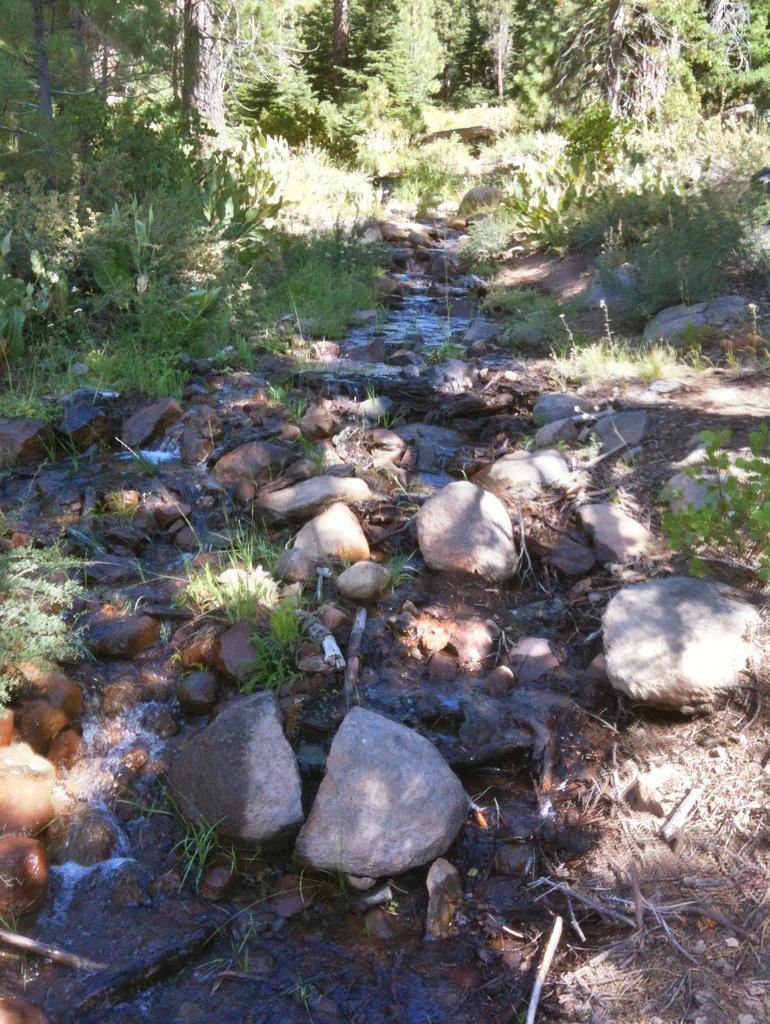What is located in the middle of the image? There is water in the middle of the image. What other objects can be seen in the image? There are stones in the image. What type of vegetation is visible at the top of the image? There are trees visible at the top of the image. What type of pan is being used to cook the trees in the image? There is no pan or cooking activity present in the image; it features water, stones, and trees. 